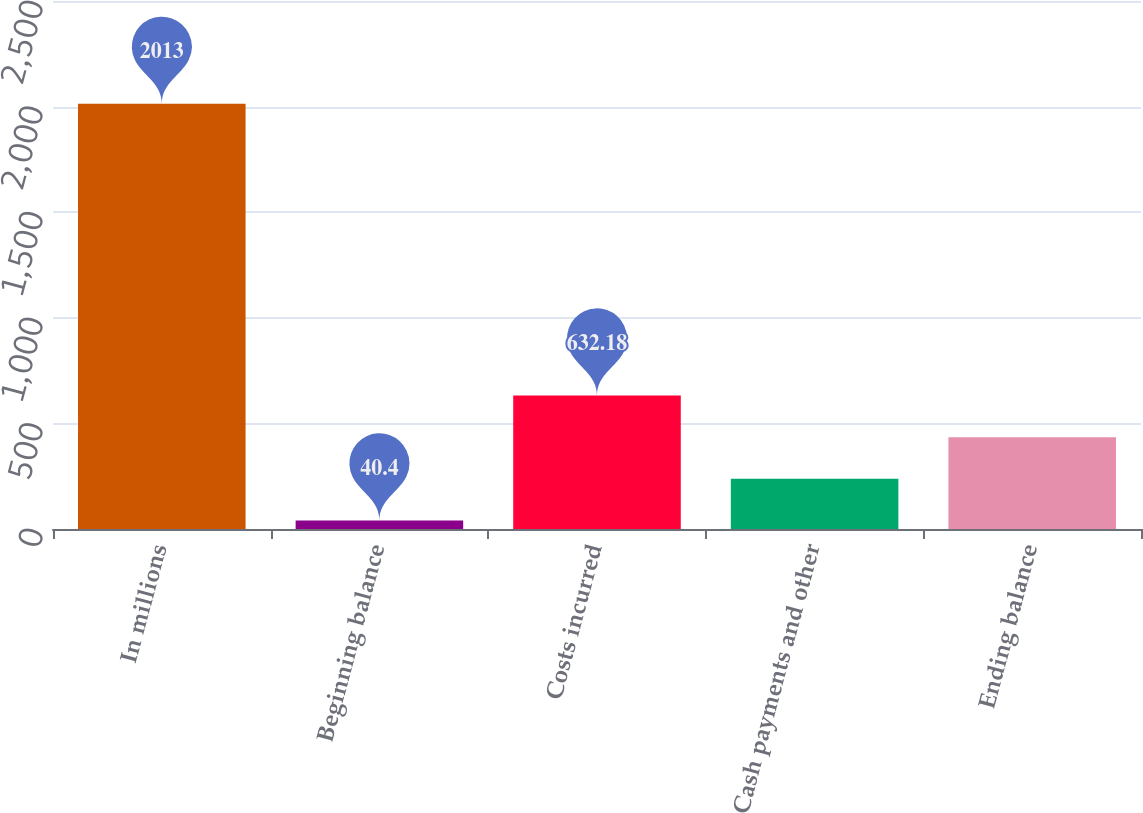<chart> <loc_0><loc_0><loc_500><loc_500><bar_chart><fcel>In millions<fcel>Beginning balance<fcel>Costs incurred<fcel>Cash payments and other<fcel>Ending balance<nl><fcel>2013<fcel>40.4<fcel>632.18<fcel>237.66<fcel>434.92<nl></chart> 